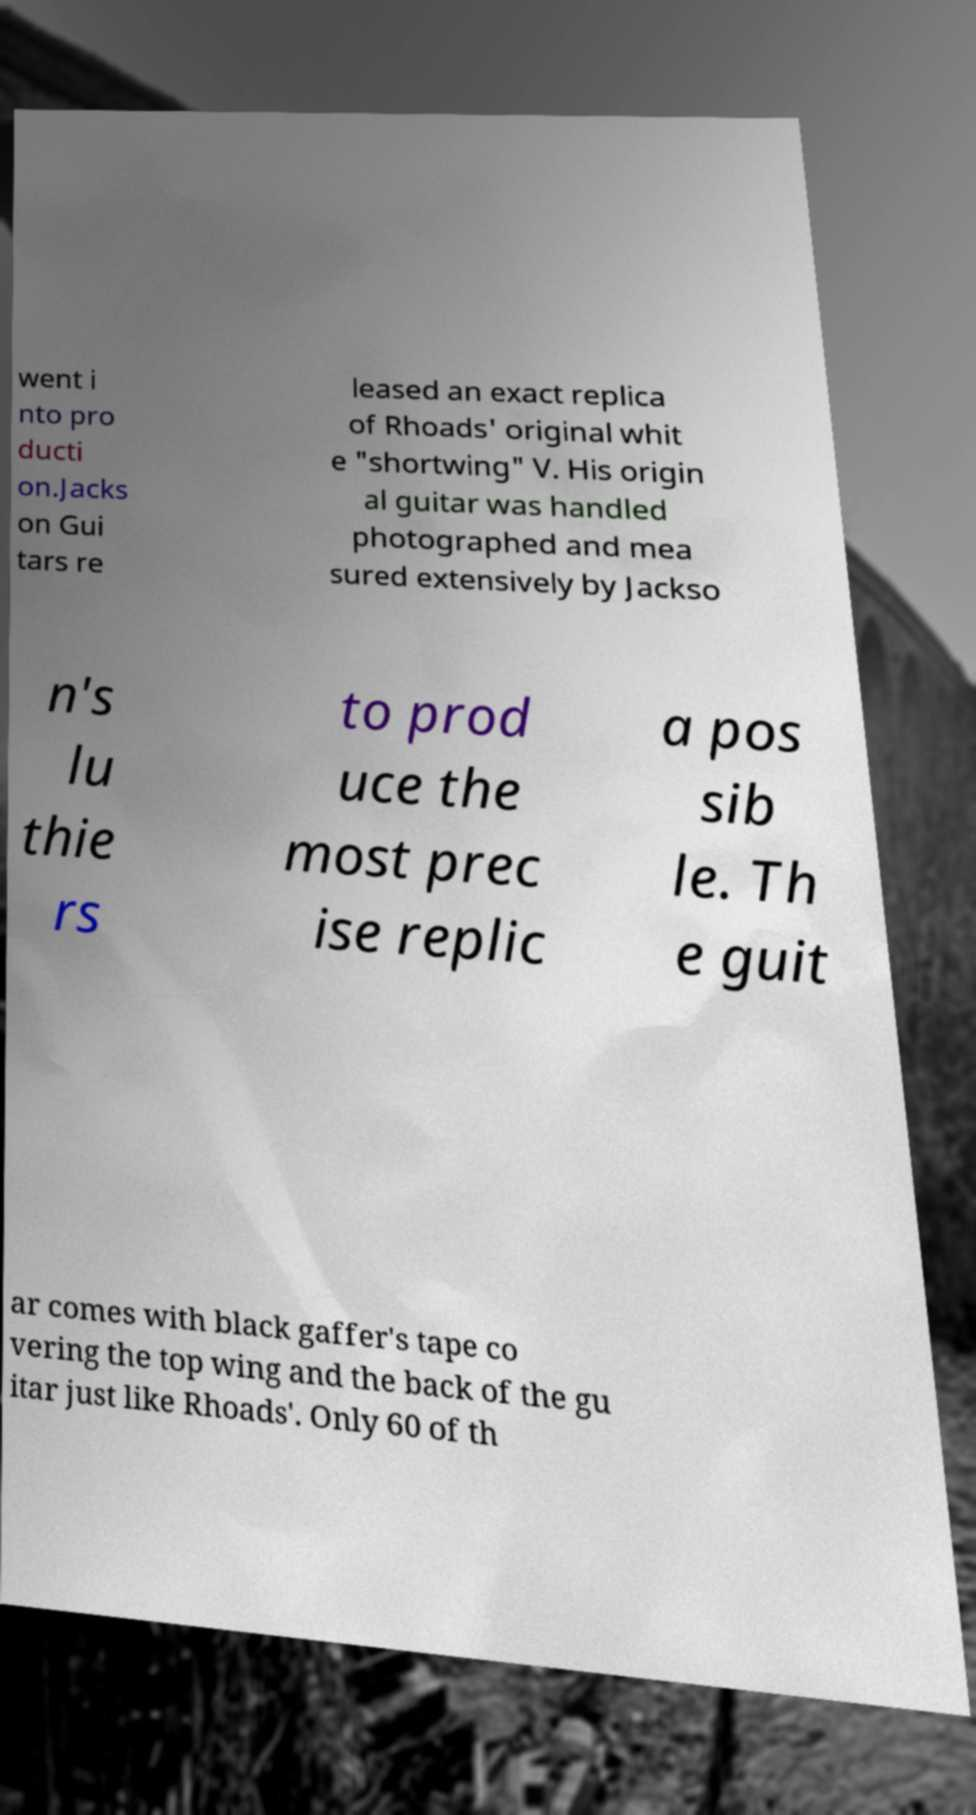There's text embedded in this image that I need extracted. Can you transcribe it verbatim? went i nto pro ducti on.Jacks on Gui tars re leased an exact replica of Rhoads' original whit e "shortwing" V. His origin al guitar was handled photographed and mea sured extensively by Jackso n's lu thie rs to prod uce the most prec ise replic a pos sib le. Th e guit ar comes with black gaffer's tape co vering the top wing and the back of the gu itar just like Rhoads'. Only 60 of th 